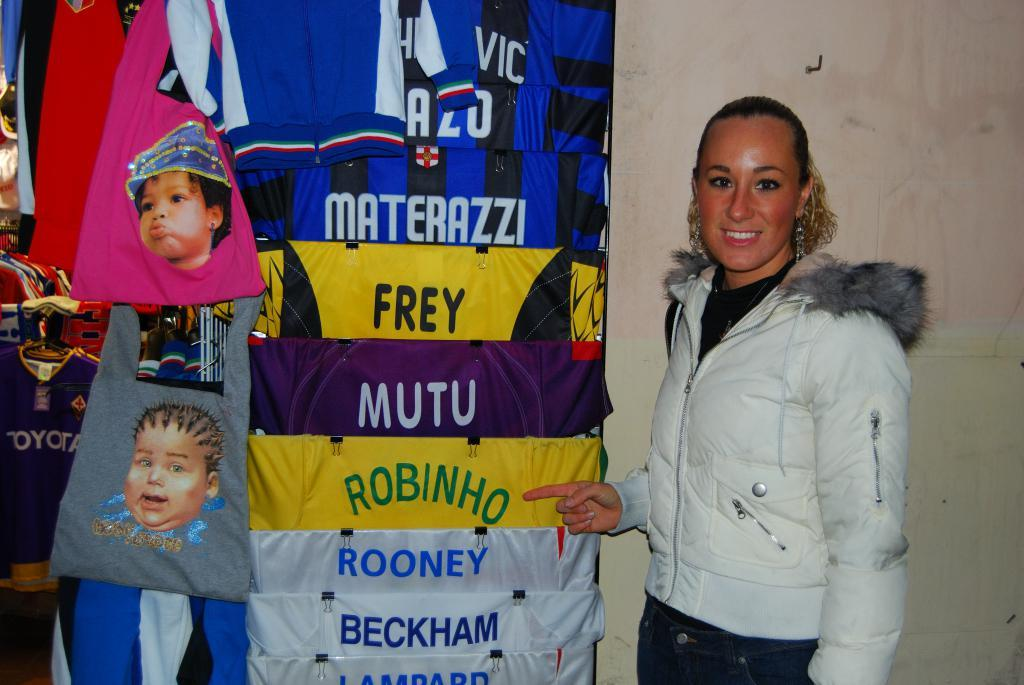What can be found on the left side of the image? There are clothes and objects on the left side of the image. What is located on the right side of the image? There is a woman on the right side of the image, as well as a wall. How is the woman depicted in the image? The woman is smiling and wearing a jacket. What type of quill is the woman holding in the image? There is no quill present in the image; the woman is not holding any object. What year is depicted in the image? The image does not depict a specific year; it is a photograph or illustration of a woman and some objects. 